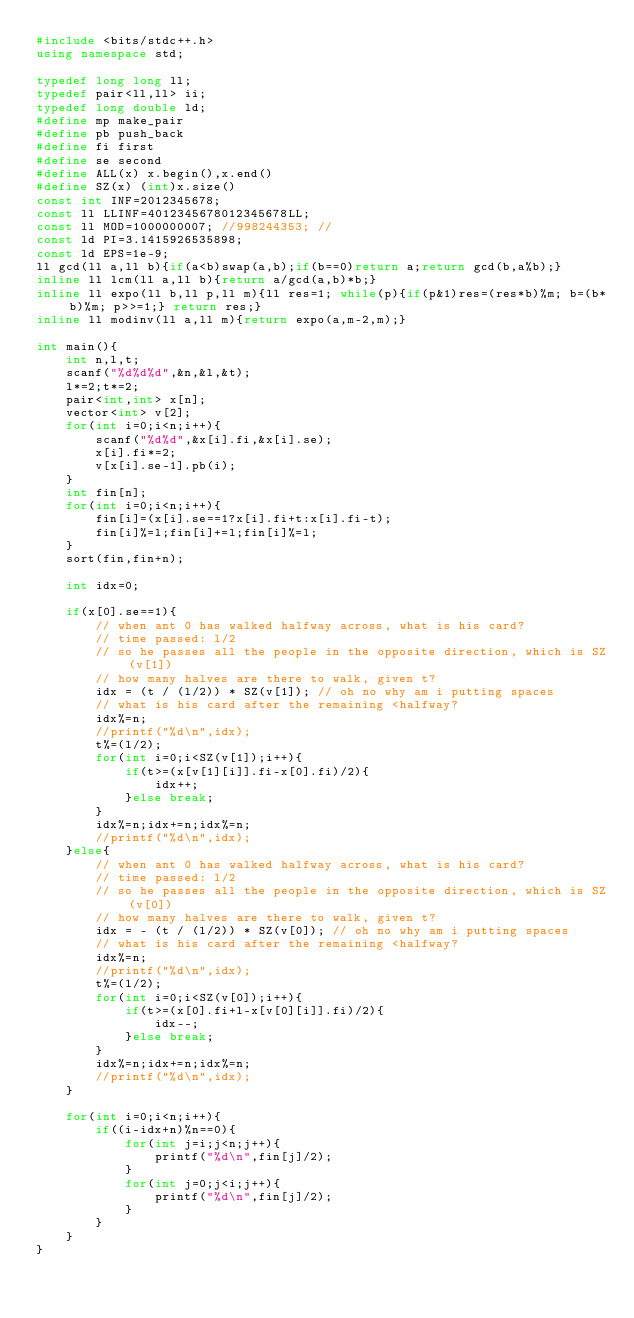<code> <loc_0><loc_0><loc_500><loc_500><_C++_>#include <bits/stdc++.h>
using namespace std;

typedef long long ll;
typedef pair<ll,ll> ii;
typedef long double ld;
#define mp make_pair
#define pb push_back
#define fi first
#define se second
#define ALL(x) x.begin(),x.end()
#define SZ(x) (int)x.size()
const int INF=2012345678;
const ll LLINF=4012345678012345678LL;
const ll MOD=1000000007; //998244353; //
const ld PI=3.1415926535898;
const ld EPS=1e-9;
ll gcd(ll a,ll b){if(a<b)swap(a,b);if(b==0)return a;return gcd(b,a%b);}
inline ll lcm(ll a,ll b){return a/gcd(a,b)*b;}
inline ll expo(ll b,ll p,ll m){ll res=1; while(p){if(p&1)res=(res*b)%m; b=(b*b)%m; p>>=1;} return res;}
inline ll modinv(ll a,ll m){return expo(a,m-2,m);}

int main(){
	int n,l,t;
	scanf("%d%d%d",&n,&l,&t);
	l*=2;t*=2;
	pair<int,int> x[n];
	vector<int> v[2];
	for(int i=0;i<n;i++){
		scanf("%d%d",&x[i].fi,&x[i].se);
		x[i].fi*=2;
		v[x[i].se-1].pb(i);
	}
	int fin[n];
	for(int i=0;i<n;i++){
		fin[i]=(x[i].se==1?x[i].fi+t:x[i].fi-t);
		fin[i]%=l;fin[i]+=l;fin[i]%=l;
	}
	sort(fin,fin+n);
	
	int idx=0;
	
	if(x[0].se==1){
		// when ant 0 has walked halfway across, what is his card?
		// time passed: l/2
		// so he passes all the people in the opposite direction, which is SZ(v[1])
		// how many halves are there to walk, given t?
		idx = (t / (l/2)) * SZ(v[1]); // oh no why am i putting spaces
		// what is his card after the remaining <halfway?
		idx%=n;
		//printf("%d\n",idx);
		t%=(l/2);
		for(int i=0;i<SZ(v[1]);i++){
			if(t>=(x[v[1][i]].fi-x[0].fi)/2){
				idx++;
			}else break;
		}
		idx%=n;idx+=n;idx%=n;
		//printf("%d\n",idx);
	}else{
		// when ant 0 has walked halfway across, what is his card?
		// time passed: l/2
		// so he passes all the people in the opposite direction, which is SZ(v[0])
		// how many halves are there to walk, given t?
		idx = - (t / (l/2)) * SZ(v[0]); // oh no why am i putting spaces
		// what is his card after the remaining <halfway?
		idx%=n;
		//printf("%d\n",idx);
		t%=(l/2);
		for(int i=0;i<SZ(v[0]);i++){
			if(t>=(x[0].fi+l-x[v[0][i]].fi)/2){
				idx--;
			}else break;
		}
		idx%=n;idx+=n;idx%=n;
		//printf("%d\n",idx);
	}
	
	for(int i=0;i<n;i++){
		if((i-idx+n)%n==0){
			for(int j=i;j<n;j++){
				printf("%d\n",fin[j]/2);
			}
			for(int j=0;j<i;j++){
				printf("%d\n",fin[j]/2);
			}
		}
	}
}
</code> 